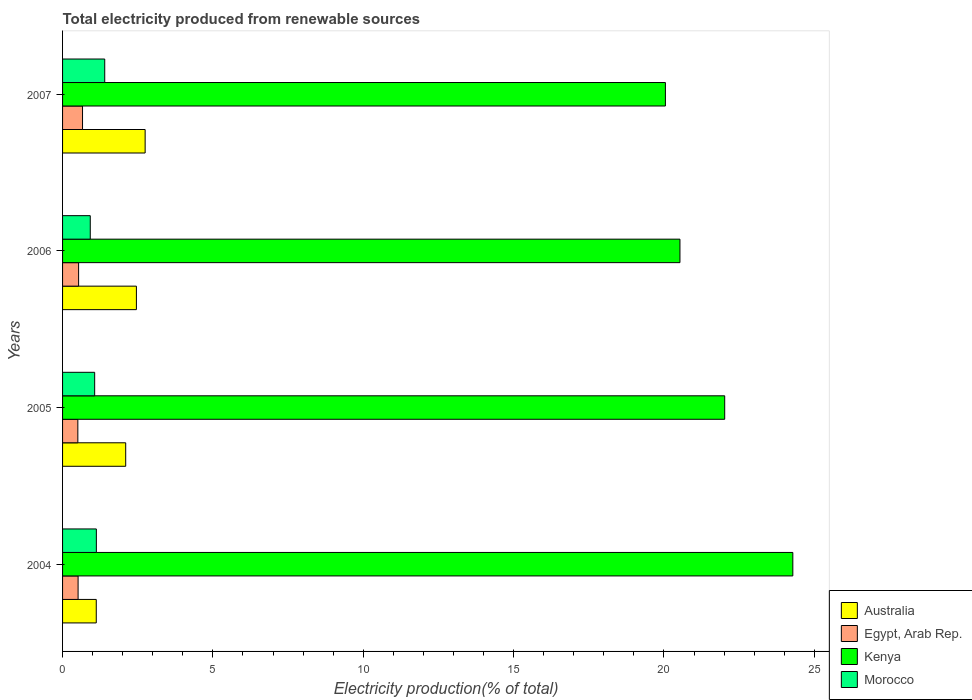How many different coloured bars are there?
Your response must be concise. 4. Are the number of bars on each tick of the Y-axis equal?
Give a very brief answer. Yes. What is the label of the 3rd group of bars from the top?
Offer a terse response. 2005. In how many cases, is the number of bars for a given year not equal to the number of legend labels?
Your answer should be compact. 0. What is the total electricity produced in Egypt, Arab Rep. in 2007?
Your answer should be compact. 0.66. Across all years, what is the maximum total electricity produced in Kenya?
Your response must be concise. 24.29. Across all years, what is the minimum total electricity produced in Australia?
Your answer should be very brief. 1.12. What is the total total electricity produced in Australia in the graph?
Keep it short and to the point. 8.42. What is the difference between the total electricity produced in Kenya in 2006 and that in 2007?
Your answer should be very brief. 0.48. What is the difference between the total electricity produced in Morocco in 2006 and the total electricity produced in Egypt, Arab Rep. in 2007?
Keep it short and to the point. 0.26. What is the average total electricity produced in Egypt, Arab Rep. per year?
Provide a short and direct response. 0.56. In the year 2005, what is the difference between the total electricity produced in Kenya and total electricity produced in Australia?
Your answer should be compact. 19.92. What is the ratio of the total electricity produced in Morocco in 2004 to that in 2006?
Provide a short and direct response. 1.22. Is the total electricity produced in Egypt, Arab Rep. in 2004 less than that in 2005?
Provide a succinct answer. No. Is the difference between the total electricity produced in Kenya in 2005 and 2006 greater than the difference between the total electricity produced in Australia in 2005 and 2006?
Ensure brevity in your answer.  Yes. What is the difference between the highest and the second highest total electricity produced in Egypt, Arab Rep.?
Keep it short and to the point. 0.13. What is the difference between the highest and the lowest total electricity produced in Kenya?
Provide a short and direct response. 4.24. Is the sum of the total electricity produced in Kenya in 2004 and 2005 greater than the maximum total electricity produced in Australia across all years?
Ensure brevity in your answer.  Yes. Is it the case that in every year, the sum of the total electricity produced in Kenya and total electricity produced in Egypt, Arab Rep. is greater than the sum of total electricity produced in Australia and total electricity produced in Morocco?
Your answer should be very brief. Yes. What does the 4th bar from the top in 2007 represents?
Provide a succinct answer. Australia. What does the 1st bar from the bottom in 2007 represents?
Provide a succinct answer. Australia. How many years are there in the graph?
Ensure brevity in your answer.  4. Are the values on the major ticks of X-axis written in scientific E-notation?
Make the answer very short. No. Does the graph contain any zero values?
Offer a very short reply. No. Where does the legend appear in the graph?
Provide a short and direct response. Bottom right. What is the title of the graph?
Provide a short and direct response. Total electricity produced from renewable sources. Does "Portugal" appear as one of the legend labels in the graph?
Offer a terse response. No. What is the Electricity production(% of total) of Australia in 2004?
Offer a terse response. 1.12. What is the Electricity production(% of total) in Egypt, Arab Rep. in 2004?
Your answer should be very brief. 0.52. What is the Electricity production(% of total) in Kenya in 2004?
Provide a succinct answer. 24.29. What is the Electricity production(% of total) of Morocco in 2004?
Offer a terse response. 1.12. What is the Electricity production(% of total) in Australia in 2005?
Offer a terse response. 2.1. What is the Electricity production(% of total) in Egypt, Arab Rep. in 2005?
Offer a terse response. 0.51. What is the Electricity production(% of total) in Kenya in 2005?
Provide a short and direct response. 22.02. What is the Electricity production(% of total) in Morocco in 2005?
Offer a very short reply. 1.07. What is the Electricity production(% of total) of Australia in 2006?
Give a very brief answer. 2.46. What is the Electricity production(% of total) in Egypt, Arab Rep. in 2006?
Make the answer very short. 0.53. What is the Electricity production(% of total) in Kenya in 2006?
Give a very brief answer. 20.53. What is the Electricity production(% of total) in Morocco in 2006?
Offer a terse response. 0.92. What is the Electricity production(% of total) in Australia in 2007?
Give a very brief answer. 2.75. What is the Electricity production(% of total) in Egypt, Arab Rep. in 2007?
Offer a terse response. 0.66. What is the Electricity production(% of total) of Kenya in 2007?
Provide a short and direct response. 20.05. What is the Electricity production(% of total) in Morocco in 2007?
Make the answer very short. 1.4. Across all years, what is the maximum Electricity production(% of total) of Australia?
Your response must be concise. 2.75. Across all years, what is the maximum Electricity production(% of total) of Egypt, Arab Rep.?
Offer a terse response. 0.66. Across all years, what is the maximum Electricity production(% of total) of Kenya?
Keep it short and to the point. 24.29. Across all years, what is the maximum Electricity production(% of total) in Morocco?
Your response must be concise. 1.4. Across all years, what is the minimum Electricity production(% of total) in Australia?
Your answer should be very brief. 1.12. Across all years, what is the minimum Electricity production(% of total) of Egypt, Arab Rep.?
Make the answer very short. 0.51. Across all years, what is the minimum Electricity production(% of total) in Kenya?
Your answer should be very brief. 20.05. Across all years, what is the minimum Electricity production(% of total) of Morocco?
Provide a short and direct response. 0.92. What is the total Electricity production(% of total) in Australia in the graph?
Provide a succinct answer. 8.42. What is the total Electricity production(% of total) of Egypt, Arab Rep. in the graph?
Your answer should be very brief. 2.22. What is the total Electricity production(% of total) in Kenya in the graph?
Your answer should be compact. 86.89. What is the total Electricity production(% of total) of Morocco in the graph?
Offer a terse response. 4.52. What is the difference between the Electricity production(% of total) in Australia in 2004 and that in 2005?
Keep it short and to the point. -0.98. What is the difference between the Electricity production(% of total) in Egypt, Arab Rep. in 2004 and that in 2005?
Make the answer very short. 0.01. What is the difference between the Electricity production(% of total) in Kenya in 2004 and that in 2005?
Make the answer very short. 2.27. What is the difference between the Electricity production(% of total) in Morocco in 2004 and that in 2005?
Your response must be concise. 0.06. What is the difference between the Electricity production(% of total) in Australia in 2004 and that in 2006?
Offer a terse response. -1.33. What is the difference between the Electricity production(% of total) in Egypt, Arab Rep. in 2004 and that in 2006?
Provide a succinct answer. -0.02. What is the difference between the Electricity production(% of total) in Kenya in 2004 and that in 2006?
Provide a short and direct response. 3.75. What is the difference between the Electricity production(% of total) of Morocco in 2004 and that in 2006?
Make the answer very short. 0.2. What is the difference between the Electricity production(% of total) of Australia in 2004 and that in 2007?
Offer a terse response. -1.63. What is the difference between the Electricity production(% of total) of Egypt, Arab Rep. in 2004 and that in 2007?
Keep it short and to the point. -0.15. What is the difference between the Electricity production(% of total) in Kenya in 2004 and that in 2007?
Give a very brief answer. 4.24. What is the difference between the Electricity production(% of total) of Morocco in 2004 and that in 2007?
Provide a short and direct response. -0.28. What is the difference between the Electricity production(% of total) in Australia in 2005 and that in 2006?
Ensure brevity in your answer.  -0.36. What is the difference between the Electricity production(% of total) in Egypt, Arab Rep. in 2005 and that in 2006?
Your answer should be compact. -0.03. What is the difference between the Electricity production(% of total) in Kenya in 2005 and that in 2006?
Your response must be concise. 1.49. What is the difference between the Electricity production(% of total) of Morocco in 2005 and that in 2006?
Make the answer very short. 0.15. What is the difference between the Electricity production(% of total) of Australia in 2005 and that in 2007?
Make the answer very short. -0.65. What is the difference between the Electricity production(% of total) of Egypt, Arab Rep. in 2005 and that in 2007?
Keep it short and to the point. -0.16. What is the difference between the Electricity production(% of total) in Kenya in 2005 and that in 2007?
Your response must be concise. 1.97. What is the difference between the Electricity production(% of total) of Morocco in 2005 and that in 2007?
Your answer should be very brief. -0.33. What is the difference between the Electricity production(% of total) in Australia in 2006 and that in 2007?
Ensure brevity in your answer.  -0.29. What is the difference between the Electricity production(% of total) of Egypt, Arab Rep. in 2006 and that in 2007?
Keep it short and to the point. -0.13. What is the difference between the Electricity production(% of total) in Kenya in 2006 and that in 2007?
Make the answer very short. 0.48. What is the difference between the Electricity production(% of total) of Morocco in 2006 and that in 2007?
Make the answer very short. -0.48. What is the difference between the Electricity production(% of total) in Australia in 2004 and the Electricity production(% of total) in Egypt, Arab Rep. in 2005?
Provide a short and direct response. 0.61. What is the difference between the Electricity production(% of total) in Australia in 2004 and the Electricity production(% of total) in Kenya in 2005?
Give a very brief answer. -20.9. What is the difference between the Electricity production(% of total) in Australia in 2004 and the Electricity production(% of total) in Morocco in 2005?
Give a very brief answer. 0.05. What is the difference between the Electricity production(% of total) of Egypt, Arab Rep. in 2004 and the Electricity production(% of total) of Kenya in 2005?
Keep it short and to the point. -21.5. What is the difference between the Electricity production(% of total) of Egypt, Arab Rep. in 2004 and the Electricity production(% of total) of Morocco in 2005?
Your response must be concise. -0.55. What is the difference between the Electricity production(% of total) of Kenya in 2004 and the Electricity production(% of total) of Morocco in 2005?
Give a very brief answer. 23.22. What is the difference between the Electricity production(% of total) of Australia in 2004 and the Electricity production(% of total) of Egypt, Arab Rep. in 2006?
Your answer should be very brief. 0.59. What is the difference between the Electricity production(% of total) of Australia in 2004 and the Electricity production(% of total) of Kenya in 2006?
Provide a succinct answer. -19.41. What is the difference between the Electricity production(% of total) of Australia in 2004 and the Electricity production(% of total) of Morocco in 2006?
Offer a very short reply. 0.2. What is the difference between the Electricity production(% of total) in Egypt, Arab Rep. in 2004 and the Electricity production(% of total) in Kenya in 2006?
Give a very brief answer. -20.02. What is the difference between the Electricity production(% of total) in Egypt, Arab Rep. in 2004 and the Electricity production(% of total) in Morocco in 2006?
Your answer should be very brief. -0.41. What is the difference between the Electricity production(% of total) of Kenya in 2004 and the Electricity production(% of total) of Morocco in 2006?
Give a very brief answer. 23.36. What is the difference between the Electricity production(% of total) of Australia in 2004 and the Electricity production(% of total) of Egypt, Arab Rep. in 2007?
Your answer should be compact. 0.46. What is the difference between the Electricity production(% of total) in Australia in 2004 and the Electricity production(% of total) in Kenya in 2007?
Make the answer very short. -18.93. What is the difference between the Electricity production(% of total) in Australia in 2004 and the Electricity production(% of total) in Morocco in 2007?
Offer a terse response. -0.28. What is the difference between the Electricity production(% of total) in Egypt, Arab Rep. in 2004 and the Electricity production(% of total) in Kenya in 2007?
Your response must be concise. -19.53. What is the difference between the Electricity production(% of total) of Egypt, Arab Rep. in 2004 and the Electricity production(% of total) of Morocco in 2007?
Keep it short and to the point. -0.89. What is the difference between the Electricity production(% of total) in Kenya in 2004 and the Electricity production(% of total) in Morocco in 2007?
Your answer should be compact. 22.88. What is the difference between the Electricity production(% of total) of Australia in 2005 and the Electricity production(% of total) of Egypt, Arab Rep. in 2006?
Keep it short and to the point. 1.57. What is the difference between the Electricity production(% of total) of Australia in 2005 and the Electricity production(% of total) of Kenya in 2006?
Offer a terse response. -18.43. What is the difference between the Electricity production(% of total) of Australia in 2005 and the Electricity production(% of total) of Morocco in 2006?
Provide a succinct answer. 1.18. What is the difference between the Electricity production(% of total) of Egypt, Arab Rep. in 2005 and the Electricity production(% of total) of Kenya in 2006?
Ensure brevity in your answer.  -20.02. What is the difference between the Electricity production(% of total) in Egypt, Arab Rep. in 2005 and the Electricity production(% of total) in Morocco in 2006?
Offer a terse response. -0.41. What is the difference between the Electricity production(% of total) in Kenya in 2005 and the Electricity production(% of total) in Morocco in 2006?
Give a very brief answer. 21.1. What is the difference between the Electricity production(% of total) of Australia in 2005 and the Electricity production(% of total) of Egypt, Arab Rep. in 2007?
Your answer should be very brief. 1.44. What is the difference between the Electricity production(% of total) in Australia in 2005 and the Electricity production(% of total) in Kenya in 2007?
Your answer should be compact. -17.95. What is the difference between the Electricity production(% of total) of Australia in 2005 and the Electricity production(% of total) of Morocco in 2007?
Provide a succinct answer. 0.7. What is the difference between the Electricity production(% of total) in Egypt, Arab Rep. in 2005 and the Electricity production(% of total) in Kenya in 2007?
Ensure brevity in your answer.  -19.54. What is the difference between the Electricity production(% of total) of Egypt, Arab Rep. in 2005 and the Electricity production(% of total) of Morocco in 2007?
Offer a terse response. -0.89. What is the difference between the Electricity production(% of total) in Kenya in 2005 and the Electricity production(% of total) in Morocco in 2007?
Offer a terse response. 20.62. What is the difference between the Electricity production(% of total) of Australia in 2006 and the Electricity production(% of total) of Egypt, Arab Rep. in 2007?
Keep it short and to the point. 1.79. What is the difference between the Electricity production(% of total) of Australia in 2006 and the Electricity production(% of total) of Kenya in 2007?
Offer a very short reply. -17.59. What is the difference between the Electricity production(% of total) of Australia in 2006 and the Electricity production(% of total) of Morocco in 2007?
Your answer should be compact. 1.05. What is the difference between the Electricity production(% of total) in Egypt, Arab Rep. in 2006 and the Electricity production(% of total) in Kenya in 2007?
Provide a succinct answer. -19.51. What is the difference between the Electricity production(% of total) of Egypt, Arab Rep. in 2006 and the Electricity production(% of total) of Morocco in 2007?
Your answer should be very brief. -0.87. What is the difference between the Electricity production(% of total) of Kenya in 2006 and the Electricity production(% of total) of Morocco in 2007?
Make the answer very short. 19.13. What is the average Electricity production(% of total) in Australia per year?
Your answer should be very brief. 2.11. What is the average Electricity production(% of total) of Egypt, Arab Rep. per year?
Keep it short and to the point. 0.56. What is the average Electricity production(% of total) of Kenya per year?
Provide a succinct answer. 21.72. What is the average Electricity production(% of total) of Morocco per year?
Make the answer very short. 1.13. In the year 2004, what is the difference between the Electricity production(% of total) of Australia and Electricity production(% of total) of Egypt, Arab Rep.?
Provide a succinct answer. 0.6. In the year 2004, what is the difference between the Electricity production(% of total) of Australia and Electricity production(% of total) of Kenya?
Keep it short and to the point. -23.16. In the year 2004, what is the difference between the Electricity production(% of total) in Australia and Electricity production(% of total) in Morocco?
Your answer should be compact. -0. In the year 2004, what is the difference between the Electricity production(% of total) of Egypt, Arab Rep. and Electricity production(% of total) of Kenya?
Give a very brief answer. -23.77. In the year 2004, what is the difference between the Electricity production(% of total) of Egypt, Arab Rep. and Electricity production(% of total) of Morocco?
Offer a very short reply. -0.61. In the year 2004, what is the difference between the Electricity production(% of total) in Kenya and Electricity production(% of total) in Morocco?
Your answer should be compact. 23.16. In the year 2005, what is the difference between the Electricity production(% of total) in Australia and Electricity production(% of total) in Egypt, Arab Rep.?
Provide a short and direct response. 1.59. In the year 2005, what is the difference between the Electricity production(% of total) in Australia and Electricity production(% of total) in Kenya?
Provide a succinct answer. -19.92. In the year 2005, what is the difference between the Electricity production(% of total) of Australia and Electricity production(% of total) of Morocco?
Your answer should be compact. 1.03. In the year 2005, what is the difference between the Electricity production(% of total) in Egypt, Arab Rep. and Electricity production(% of total) in Kenya?
Your answer should be very brief. -21.51. In the year 2005, what is the difference between the Electricity production(% of total) in Egypt, Arab Rep. and Electricity production(% of total) in Morocco?
Your answer should be compact. -0.56. In the year 2005, what is the difference between the Electricity production(% of total) of Kenya and Electricity production(% of total) of Morocco?
Offer a terse response. 20.95. In the year 2006, what is the difference between the Electricity production(% of total) in Australia and Electricity production(% of total) in Egypt, Arab Rep.?
Provide a short and direct response. 1.92. In the year 2006, what is the difference between the Electricity production(% of total) in Australia and Electricity production(% of total) in Kenya?
Give a very brief answer. -18.08. In the year 2006, what is the difference between the Electricity production(% of total) of Australia and Electricity production(% of total) of Morocco?
Offer a terse response. 1.53. In the year 2006, what is the difference between the Electricity production(% of total) of Egypt, Arab Rep. and Electricity production(% of total) of Kenya?
Your answer should be compact. -20. In the year 2006, what is the difference between the Electricity production(% of total) of Egypt, Arab Rep. and Electricity production(% of total) of Morocco?
Keep it short and to the point. -0.39. In the year 2006, what is the difference between the Electricity production(% of total) of Kenya and Electricity production(% of total) of Morocco?
Make the answer very short. 19.61. In the year 2007, what is the difference between the Electricity production(% of total) in Australia and Electricity production(% of total) in Egypt, Arab Rep.?
Your answer should be very brief. 2.08. In the year 2007, what is the difference between the Electricity production(% of total) in Australia and Electricity production(% of total) in Kenya?
Ensure brevity in your answer.  -17.3. In the year 2007, what is the difference between the Electricity production(% of total) in Australia and Electricity production(% of total) in Morocco?
Offer a terse response. 1.34. In the year 2007, what is the difference between the Electricity production(% of total) of Egypt, Arab Rep. and Electricity production(% of total) of Kenya?
Offer a very short reply. -19.38. In the year 2007, what is the difference between the Electricity production(% of total) in Egypt, Arab Rep. and Electricity production(% of total) in Morocco?
Offer a terse response. -0.74. In the year 2007, what is the difference between the Electricity production(% of total) in Kenya and Electricity production(% of total) in Morocco?
Offer a terse response. 18.65. What is the ratio of the Electricity production(% of total) of Australia in 2004 to that in 2005?
Make the answer very short. 0.53. What is the ratio of the Electricity production(% of total) in Egypt, Arab Rep. in 2004 to that in 2005?
Your answer should be very brief. 1.02. What is the ratio of the Electricity production(% of total) in Kenya in 2004 to that in 2005?
Offer a terse response. 1.1. What is the ratio of the Electricity production(% of total) of Morocco in 2004 to that in 2005?
Your answer should be very brief. 1.05. What is the ratio of the Electricity production(% of total) in Australia in 2004 to that in 2006?
Your response must be concise. 0.46. What is the ratio of the Electricity production(% of total) in Egypt, Arab Rep. in 2004 to that in 2006?
Keep it short and to the point. 0.97. What is the ratio of the Electricity production(% of total) in Kenya in 2004 to that in 2006?
Make the answer very short. 1.18. What is the ratio of the Electricity production(% of total) of Morocco in 2004 to that in 2006?
Ensure brevity in your answer.  1.22. What is the ratio of the Electricity production(% of total) in Australia in 2004 to that in 2007?
Your answer should be compact. 0.41. What is the ratio of the Electricity production(% of total) of Egypt, Arab Rep. in 2004 to that in 2007?
Your answer should be compact. 0.78. What is the ratio of the Electricity production(% of total) of Kenya in 2004 to that in 2007?
Offer a very short reply. 1.21. What is the ratio of the Electricity production(% of total) of Morocco in 2004 to that in 2007?
Provide a succinct answer. 0.8. What is the ratio of the Electricity production(% of total) in Australia in 2005 to that in 2006?
Offer a terse response. 0.85. What is the ratio of the Electricity production(% of total) in Egypt, Arab Rep. in 2005 to that in 2006?
Keep it short and to the point. 0.95. What is the ratio of the Electricity production(% of total) of Kenya in 2005 to that in 2006?
Give a very brief answer. 1.07. What is the ratio of the Electricity production(% of total) in Morocco in 2005 to that in 2006?
Provide a succinct answer. 1.16. What is the ratio of the Electricity production(% of total) of Australia in 2005 to that in 2007?
Ensure brevity in your answer.  0.76. What is the ratio of the Electricity production(% of total) in Egypt, Arab Rep. in 2005 to that in 2007?
Your response must be concise. 0.76. What is the ratio of the Electricity production(% of total) of Kenya in 2005 to that in 2007?
Your answer should be very brief. 1.1. What is the ratio of the Electricity production(% of total) of Morocco in 2005 to that in 2007?
Make the answer very short. 0.76. What is the ratio of the Electricity production(% of total) in Australia in 2006 to that in 2007?
Make the answer very short. 0.89. What is the ratio of the Electricity production(% of total) in Egypt, Arab Rep. in 2006 to that in 2007?
Offer a terse response. 0.8. What is the ratio of the Electricity production(% of total) in Kenya in 2006 to that in 2007?
Your answer should be very brief. 1.02. What is the ratio of the Electricity production(% of total) in Morocco in 2006 to that in 2007?
Ensure brevity in your answer.  0.66. What is the difference between the highest and the second highest Electricity production(% of total) of Australia?
Provide a succinct answer. 0.29. What is the difference between the highest and the second highest Electricity production(% of total) in Egypt, Arab Rep.?
Provide a succinct answer. 0.13. What is the difference between the highest and the second highest Electricity production(% of total) of Kenya?
Keep it short and to the point. 2.27. What is the difference between the highest and the second highest Electricity production(% of total) of Morocco?
Provide a succinct answer. 0.28. What is the difference between the highest and the lowest Electricity production(% of total) in Australia?
Offer a terse response. 1.63. What is the difference between the highest and the lowest Electricity production(% of total) of Egypt, Arab Rep.?
Your answer should be very brief. 0.16. What is the difference between the highest and the lowest Electricity production(% of total) in Kenya?
Provide a short and direct response. 4.24. What is the difference between the highest and the lowest Electricity production(% of total) in Morocco?
Offer a very short reply. 0.48. 